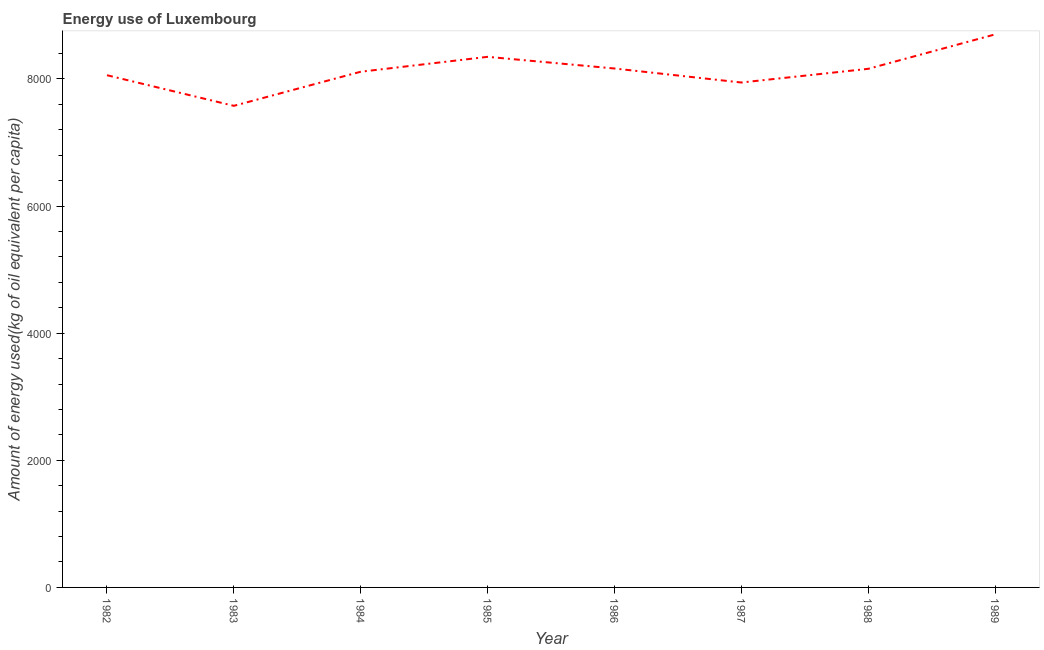What is the amount of energy used in 1982?
Make the answer very short. 8057.81. Across all years, what is the maximum amount of energy used?
Provide a succinct answer. 8699.94. Across all years, what is the minimum amount of energy used?
Keep it short and to the point. 7576.21. In which year was the amount of energy used minimum?
Make the answer very short. 1983. What is the sum of the amount of energy used?
Your answer should be compact. 6.51e+04. What is the difference between the amount of energy used in 1984 and 1989?
Your response must be concise. -587.26. What is the average amount of energy used per year?
Provide a short and direct response. 8132.31. What is the median amount of energy used?
Ensure brevity in your answer.  8135.55. In how many years, is the amount of energy used greater than 4800 kg?
Provide a succinct answer. 8. What is the ratio of the amount of energy used in 1987 to that in 1989?
Ensure brevity in your answer.  0.91. Is the amount of energy used in 1985 less than that in 1986?
Give a very brief answer. No. What is the difference between the highest and the second highest amount of energy used?
Make the answer very short. 353.01. What is the difference between the highest and the lowest amount of energy used?
Give a very brief answer. 1123.73. Does the amount of energy used monotonically increase over the years?
Give a very brief answer. No. How many lines are there?
Ensure brevity in your answer.  1. How many years are there in the graph?
Offer a very short reply. 8. Are the values on the major ticks of Y-axis written in scientific E-notation?
Ensure brevity in your answer.  No. Does the graph contain any zero values?
Offer a very short reply. No. What is the title of the graph?
Your answer should be compact. Energy use of Luxembourg. What is the label or title of the Y-axis?
Keep it short and to the point. Amount of energy used(kg of oil equivalent per capita). What is the Amount of energy used(kg of oil equivalent per capita) in 1982?
Keep it short and to the point. 8057.81. What is the Amount of energy used(kg of oil equivalent per capita) in 1983?
Give a very brief answer. 7576.21. What is the Amount of energy used(kg of oil equivalent per capita) of 1984?
Your answer should be compact. 8112.68. What is the Amount of energy used(kg of oil equivalent per capita) of 1985?
Offer a very short reply. 8346.93. What is the Amount of energy used(kg of oil equivalent per capita) of 1986?
Provide a succinct answer. 8163.55. What is the Amount of energy used(kg of oil equivalent per capita) in 1987?
Keep it short and to the point. 7942.95. What is the Amount of energy used(kg of oil equivalent per capita) in 1988?
Provide a succinct answer. 8158.43. What is the Amount of energy used(kg of oil equivalent per capita) of 1989?
Your answer should be very brief. 8699.94. What is the difference between the Amount of energy used(kg of oil equivalent per capita) in 1982 and 1983?
Your answer should be compact. 481.6. What is the difference between the Amount of energy used(kg of oil equivalent per capita) in 1982 and 1984?
Offer a terse response. -54.87. What is the difference between the Amount of energy used(kg of oil equivalent per capita) in 1982 and 1985?
Offer a terse response. -289.12. What is the difference between the Amount of energy used(kg of oil equivalent per capita) in 1982 and 1986?
Provide a succinct answer. -105.74. What is the difference between the Amount of energy used(kg of oil equivalent per capita) in 1982 and 1987?
Make the answer very short. 114.86. What is the difference between the Amount of energy used(kg of oil equivalent per capita) in 1982 and 1988?
Provide a succinct answer. -100.62. What is the difference between the Amount of energy used(kg of oil equivalent per capita) in 1982 and 1989?
Keep it short and to the point. -642.13. What is the difference between the Amount of energy used(kg of oil equivalent per capita) in 1983 and 1984?
Your answer should be compact. -536.47. What is the difference between the Amount of energy used(kg of oil equivalent per capita) in 1983 and 1985?
Provide a short and direct response. -770.72. What is the difference between the Amount of energy used(kg of oil equivalent per capita) in 1983 and 1986?
Offer a very short reply. -587.34. What is the difference between the Amount of energy used(kg of oil equivalent per capita) in 1983 and 1987?
Offer a very short reply. -366.74. What is the difference between the Amount of energy used(kg of oil equivalent per capita) in 1983 and 1988?
Make the answer very short. -582.23. What is the difference between the Amount of energy used(kg of oil equivalent per capita) in 1983 and 1989?
Your response must be concise. -1123.73. What is the difference between the Amount of energy used(kg of oil equivalent per capita) in 1984 and 1985?
Your answer should be very brief. -234.25. What is the difference between the Amount of energy used(kg of oil equivalent per capita) in 1984 and 1986?
Make the answer very short. -50.87. What is the difference between the Amount of energy used(kg of oil equivalent per capita) in 1984 and 1987?
Provide a succinct answer. 169.73. What is the difference between the Amount of energy used(kg of oil equivalent per capita) in 1984 and 1988?
Your answer should be very brief. -45.76. What is the difference between the Amount of energy used(kg of oil equivalent per capita) in 1984 and 1989?
Your answer should be very brief. -587.26. What is the difference between the Amount of energy used(kg of oil equivalent per capita) in 1985 and 1986?
Your answer should be compact. 183.38. What is the difference between the Amount of energy used(kg of oil equivalent per capita) in 1985 and 1987?
Your response must be concise. 403.98. What is the difference between the Amount of energy used(kg of oil equivalent per capita) in 1985 and 1988?
Keep it short and to the point. 188.49. What is the difference between the Amount of energy used(kg of oil equivalent per capita) in 1985 and 1989?
Ensure brevity in your answer.  -353.01. What is the difference between the Amount of energy used(kg of oil equivalent per capita) in 1986 and 1987?
Your answer should be very brief. 220.6. What is the difference between the Amount of energy used(kg of oil equivalent per capita) in 1986 and 1988?
Give a very brief answer. 5.12. What is the difference between the Amount of energy used(kg of oil equivalent per capita) in 1986 and 1989?
Offer a terse response. -536.39. What is the difference between the Amount of energy used(kg of oil equivalent per capita) in 1987 and 1988?
Keep it short and to the point. -215.49. What is the difference between the Amount of energy used(kg of oil equivalent per capita) in 1987 and 1989?
Make the answer very short. -756.99. What is the difference between the Amount of energy used(kg of oil equivalent per capita) in 1988 and 1989?
Provide a short and direct response. -541.5. What is the ratio of the Amount of energy used(kg of oil equivalent per capita) in 1982 to that in 1983?
Give a very brief answer. 1.06. What is the ratio of the Amount of energy used(kg of oil equivalent per capita) in 1982 to that in 1985?
Offer a very short reply. 0.96. What is the ratio of the Amount of energy used(kg of oil equivalent per capita) in 1982 to that in 1986?
Your response must be concise. 0.99. What is the ratio of the Amount of energy used(kg of oil equivalent per capita) in 1982 to that in 1988?
Your answer should be very brief. 0.99. What is the ratio of the Amount of energy used(kg of oil equivalent per capita) in 1982 to that in 1989?
Give a very brief answer. 0.93. What is the ratio of the Amount of energy used(kg of oil equivalent per capita) in 1983 to that in 1984?
Offer a very short reply. 0.93. What is the ratio of the Amount of energy used(kg of oil equivalent per capita) in 1983 to that in 1985?
Your answer should be very brief. 0.91. What is the ratio of the Amount of energy used(kg of oil equivalent per capita) in 1983 to that in 1986?
Offer a very short reply. 0.93. What is the ratio of the Amount of energy used(kg of oil equivalent per capita) in 1983 to that in 1987?
Ensure brevity in your answer.  0.95. What is the ratio of the Amount of energy used(kg of oil equivalent per capita) in 1983 to that in 1988?
Provide a succinct answer. 0.93. What is the ratio of the Amount of energy used(kg of oil equivalent per capita) in 1983 to that in 1989?
Provide a short and direct response. 0.87. What is the ratio of the Amount of energy used(kg of oil equivalent per capita) in 1984 to that in 1989?
Your response must be concise. 0.93. What is the ratio of the Amount of energy used(kg of oil equivalent per capita) in 1985 to that in 1987?
Offer a very short reply. 1.05. What is the ratio of the Amount of energy used(kg of oil equivalent per capita) in 1986 to that in 1987?
Your response must be concise. 1.03. What is the ratio of the Amount of energy used(kg of oil equivalent per capita) in 1986 to that in 1988?
Your answer should be very brief. 1. What is the ratio of the Amount of energy used(kg of oil equivalent per capita) in 1986 to that in 1989?
Provide a short and direct response. 0.94. What is the ratio of the Amount of energy used(kg of oil equivalent per capita) in 1988 to that in 1989?
Keep it short and to the point. 0.94. 